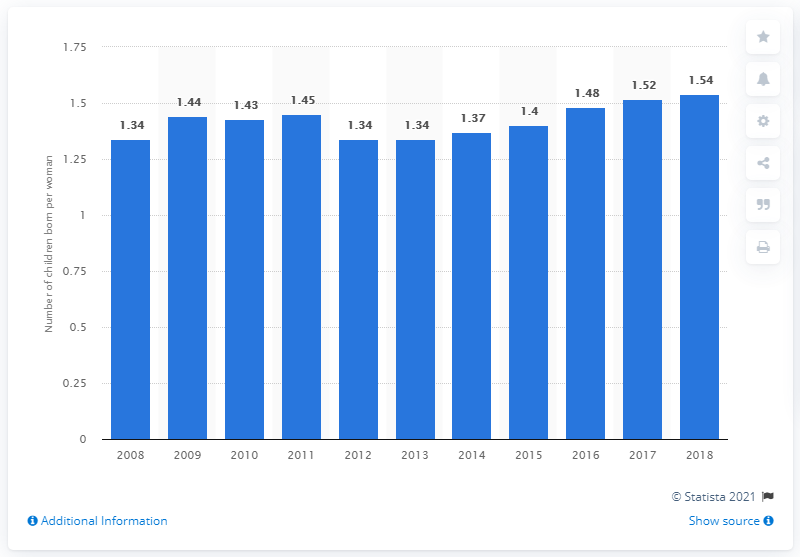Point out several critical features in this image. In 2018, Slovakia's fertility rate was 1.54. 